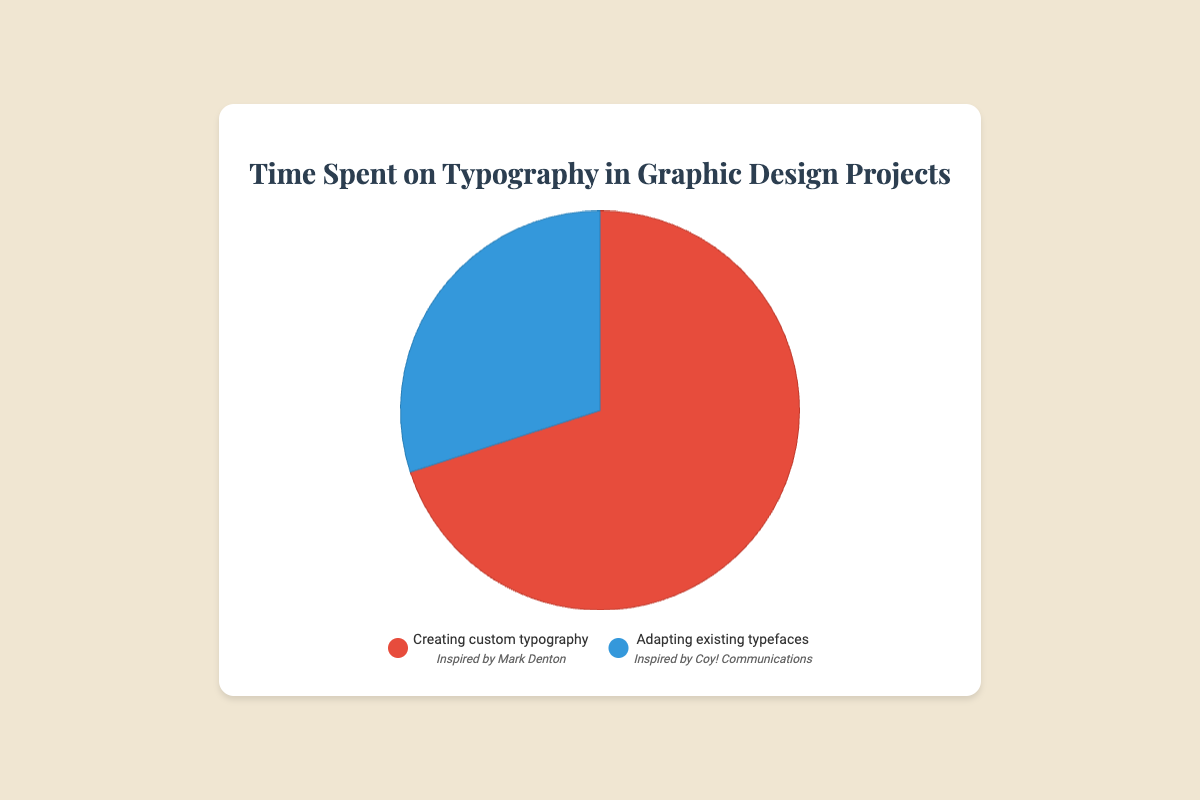What's the distribution of time spent on creating custom typography vs. adapting existing typefaces? The pie chart shows 70% of the time is spent on creating custom typography and 30% on adapting existing typefaces.
Answer: 70% on custom typography and 30% on existing typefaces Which task, creating custom typography or adapting existing typefaces, takes up more time? By looking at the pie chart, creating custom typography has a larger section compared to adapting existing typefaces.
Answer: Creating custom typography What is the percentage of time spent on visualizing tasks related to Mark Denton? The task "Creating custom typography," which occupies 70% of the pie chart, is related to Mark Denton.
Answer: 70% How does the time spent on tasks related to Coy! Communications compare to time spent on tasks related to Mark Denton? The pie chart shows 30% of the time is spent on adapting existing typefaces related to Coy! Communications, while 70% is spent on creating custom typography related to Mark Denton. Therefore, more time is spent on tasks related to Mark Denton.
Answer: Tasks related to Mark Denton take more time If one were to spend a total of 100 hours on a project, how many hours would be devoted to custom typography creation? Given that 70% of the time is allocated to creating custom typography, we calculate 70% of 100 hours, which is 70 hours.
Answer: 70 hours For a project, if the total time spent on tasks is 50 hours, how much time was spent adapting existing typefaces? With 30% of the time spent on adapting existing typefaces, we calculate 30% of 50 hours, which is 15 hours.
Answer: 15 hours What color represents the time spent on adapting existing typefaces in the pie chart? The pie chart uses a blue color to indicate the time spent adapting existing typefaces.
Answer: Blue How much more time is spent on creating custom typography compared to adapting existing typefaces? Creating custom typography occupies 70% of the time, while adapting existing typefaces occupies 30%. The difference is 70% - 30% = 40%.
Answer: 40% What entity is related to the task that occupies the largest section of the pie chart? The largest section of the pie chart, which is 70%, is for creating custom typography and is related to Mark Denton.
Answer: Mark Denton What is the ratio of time spent on custom typography creation to time spent on adapting existing typefaces? The time spent on custom typography creation is 70%, and on adapting existing typefaces is 30%. The ratio is 70:30, which simplifies to 7:3.
Answer: 7:3 